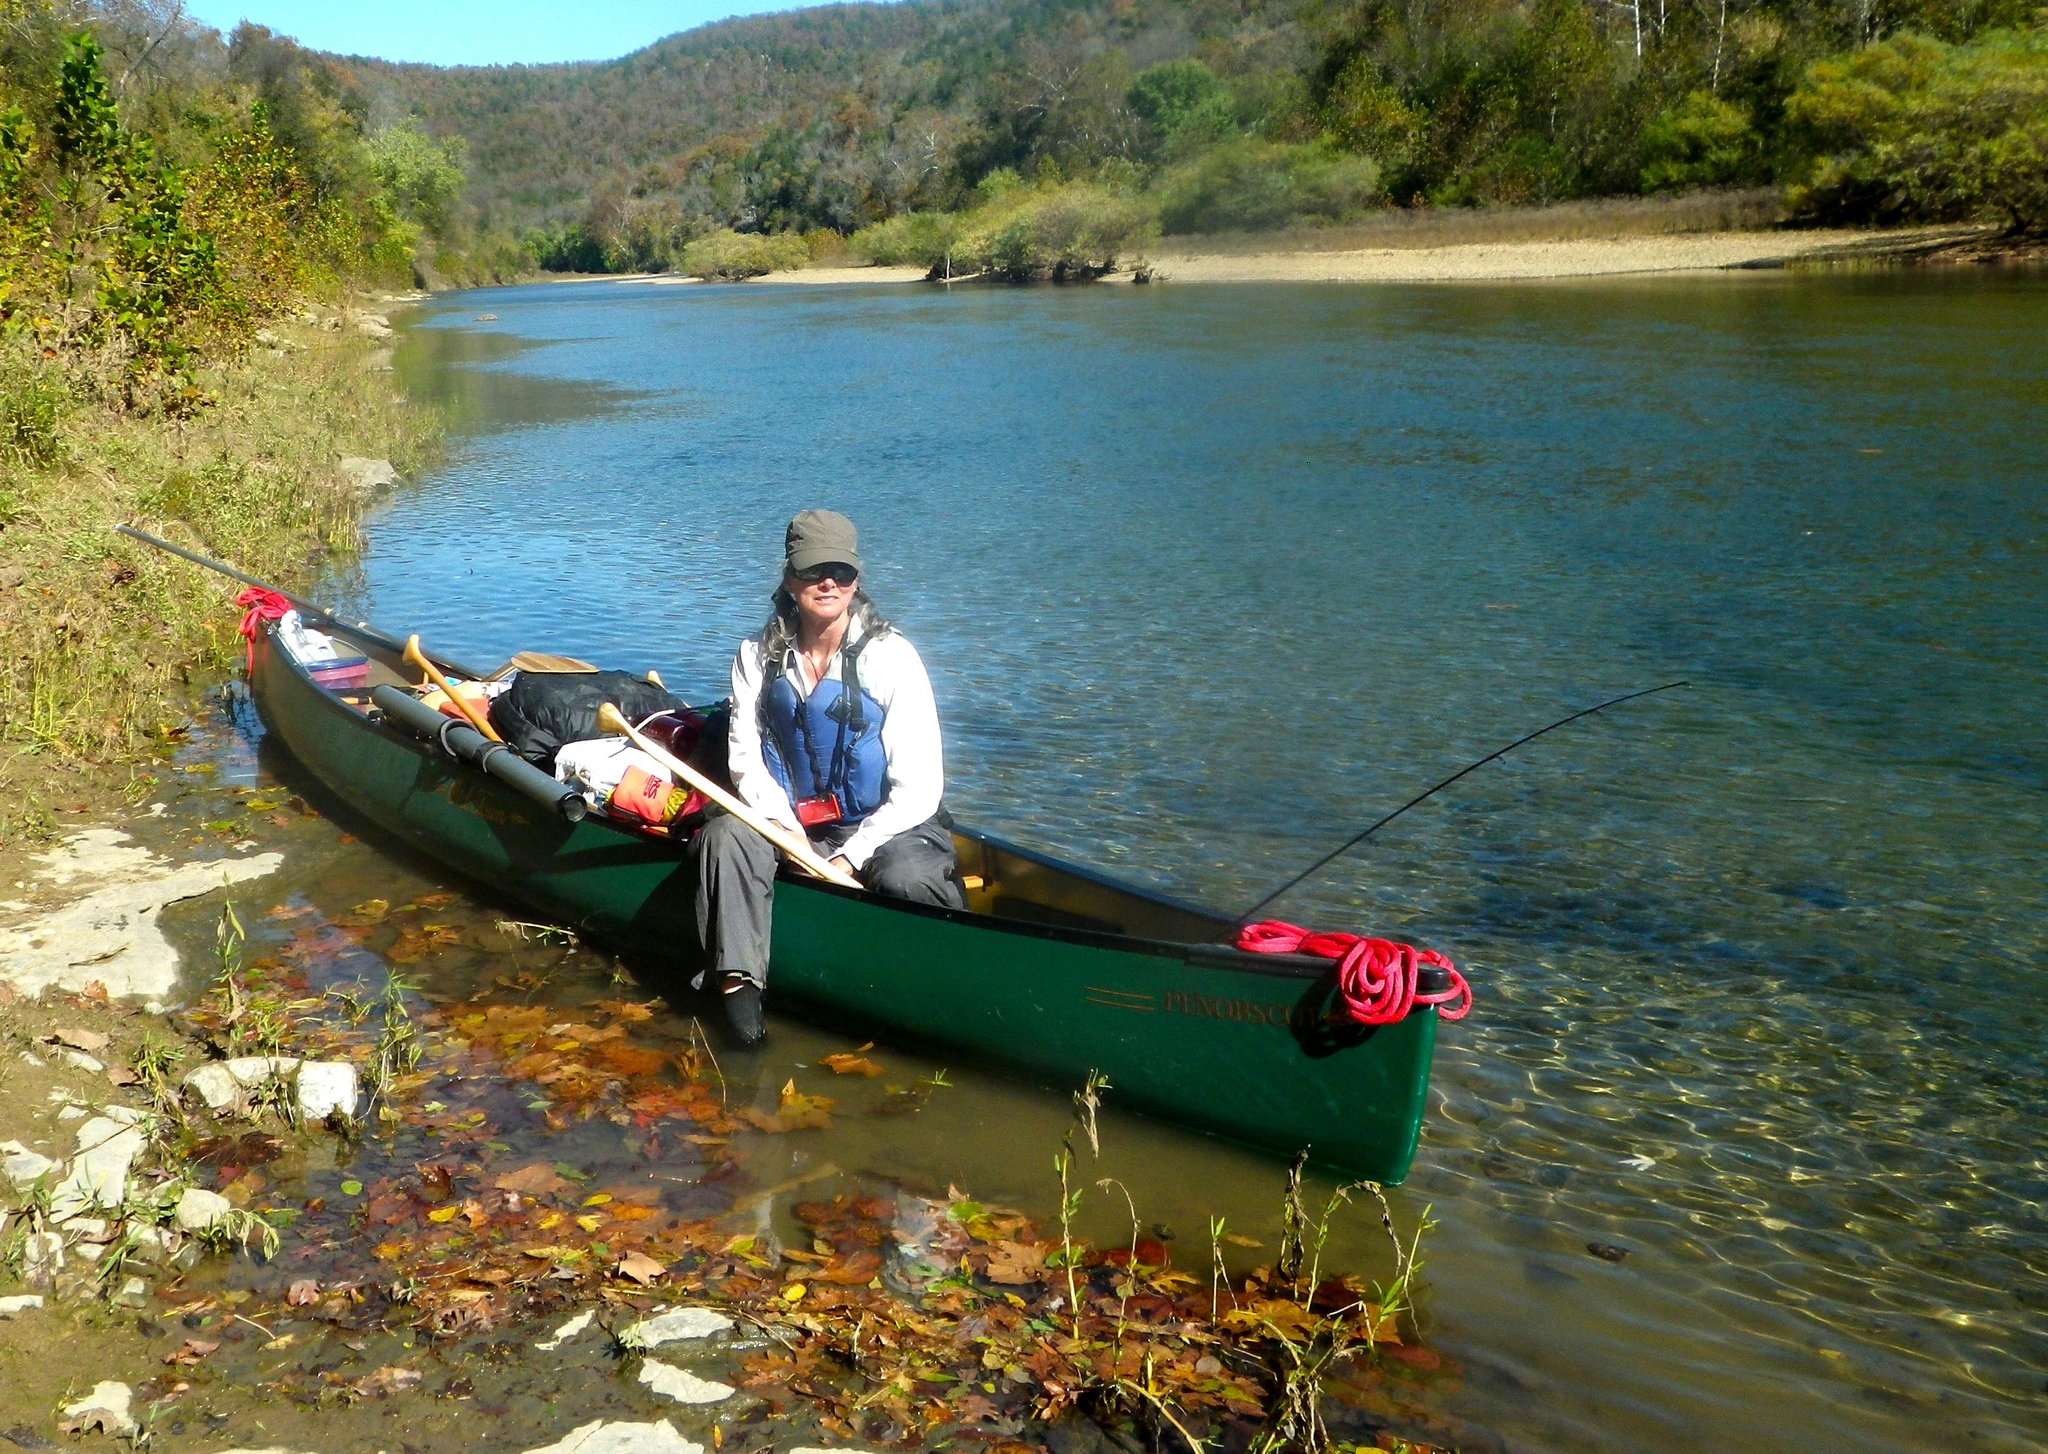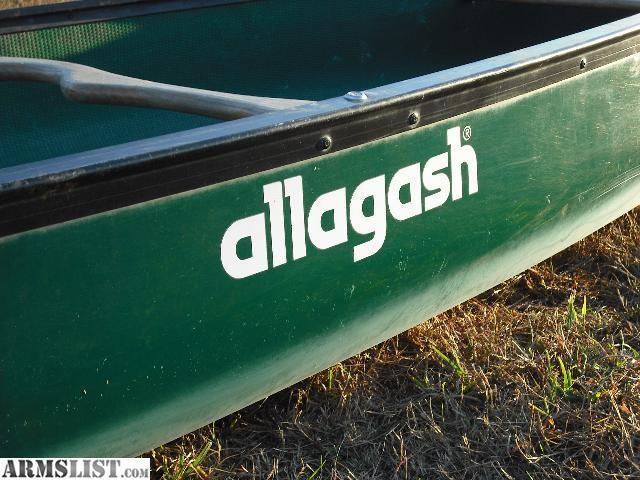The first image is the image on the left, the second image is the image on the right. Given the left and right images, does the statement "There are not human beings visible in at least one image." hold true? Answer yes or no. Yes. 